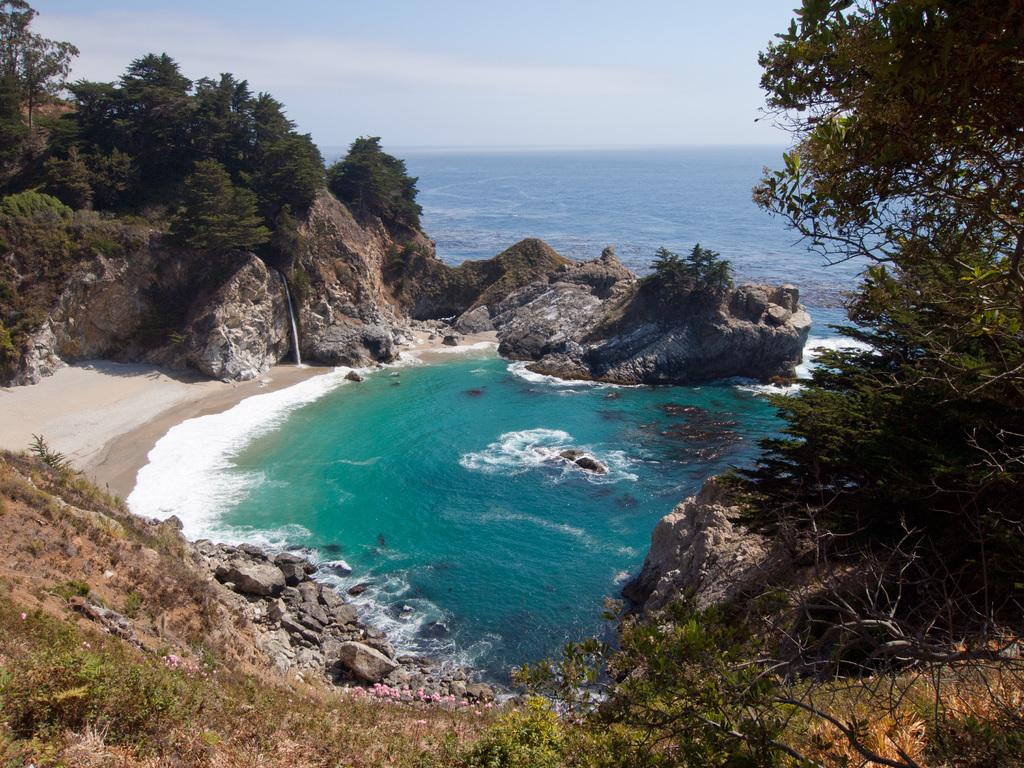What is the primary element visible in the image? There is water in the image. What other objects or features can be seen in the image? There are rocks and trees visible in the image. What can be seen in the background of the image? The sky is visible in the background of the image. What type of cake is being served on the rocks in the image? There is no cake present in the image; it features water, rocks, and trees. 